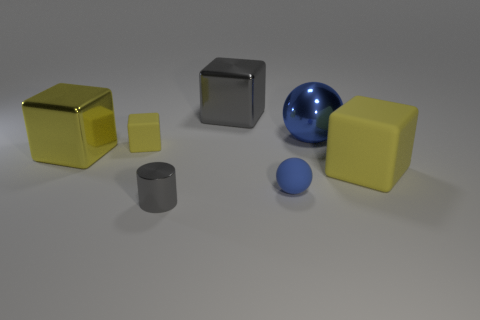What shape is the small rubber thing that is the same color as the large matte cube?
Give a very brief answer. Cube. What number of cylinders are small matte things or small gray metallic objects?
Your response must be concise. 1. There is a sphere that is in front of the shiny cube that is left of the small yellow rubber cube; what is its color?
Keep it short and to the point. Blue. There is a small ball; does it have the same color as the metal thing on the left side of the tiny gray cylinder?
Your answer should be compact. No. There is a blue sphere that is the same material as the gray cube; what size is it?
Make the answer very short. Large. There is a thing that is the same color as the tiny cylinder; what is its size?
Offer a terse response. Large. Do the metal sphere and the cylinder have the same color?
Ensure brevity in your answer.  No. Are there any cubes behind the yellow rubber thing that is right of the metallic block that is behind the small block?
Your response must be concise. Yes. What number of yellow objects have the same size as the metallic ball?
Your answer should be compact. 2. There is a yellow rubber block that is right of the big gray thing; is its size the same as the gray object in front of the big gray shiny block?
Offer a very short reply. No. 